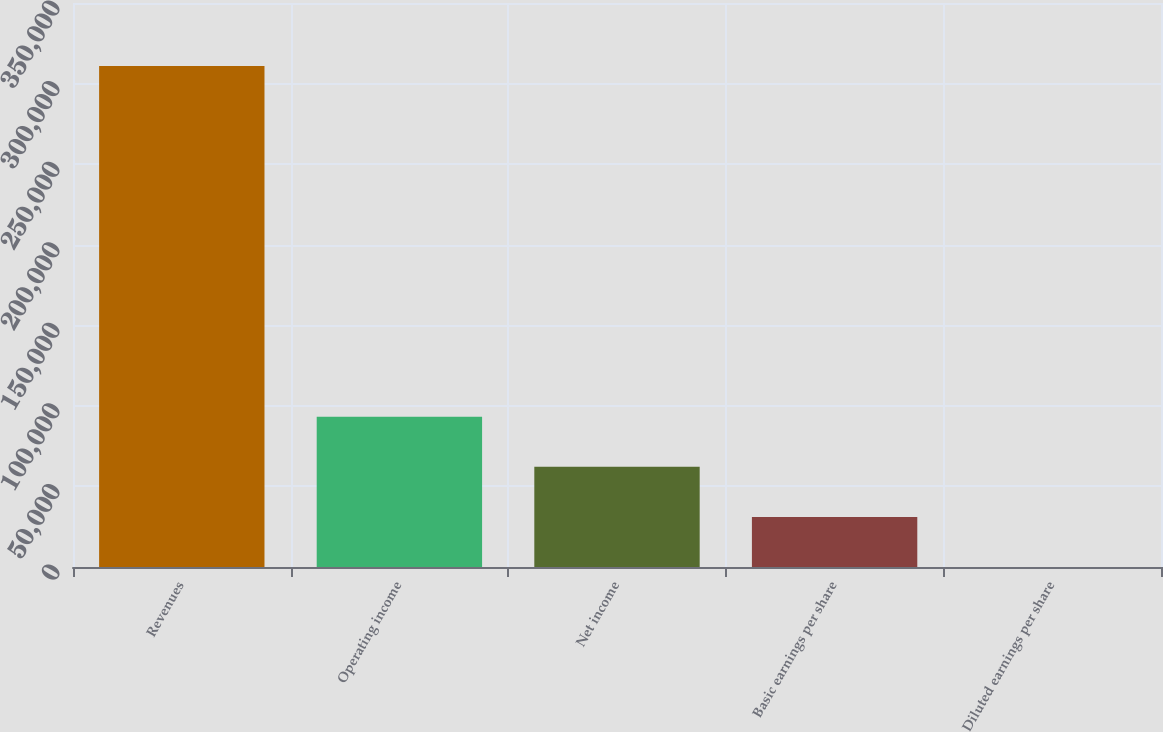<chart> <loc_0><loc_0><loc_500><loc_500><bar_chart><fcel>Revenues<fcel>Operating income<fcel>Net income<fcel>Basic earnings per share<fcel>Diluted earnings per share<nl><fcel>310980<fcel>93294.4<fcel>62196.4<fcel>31098.5<fcel>0.53<nl></chart> 